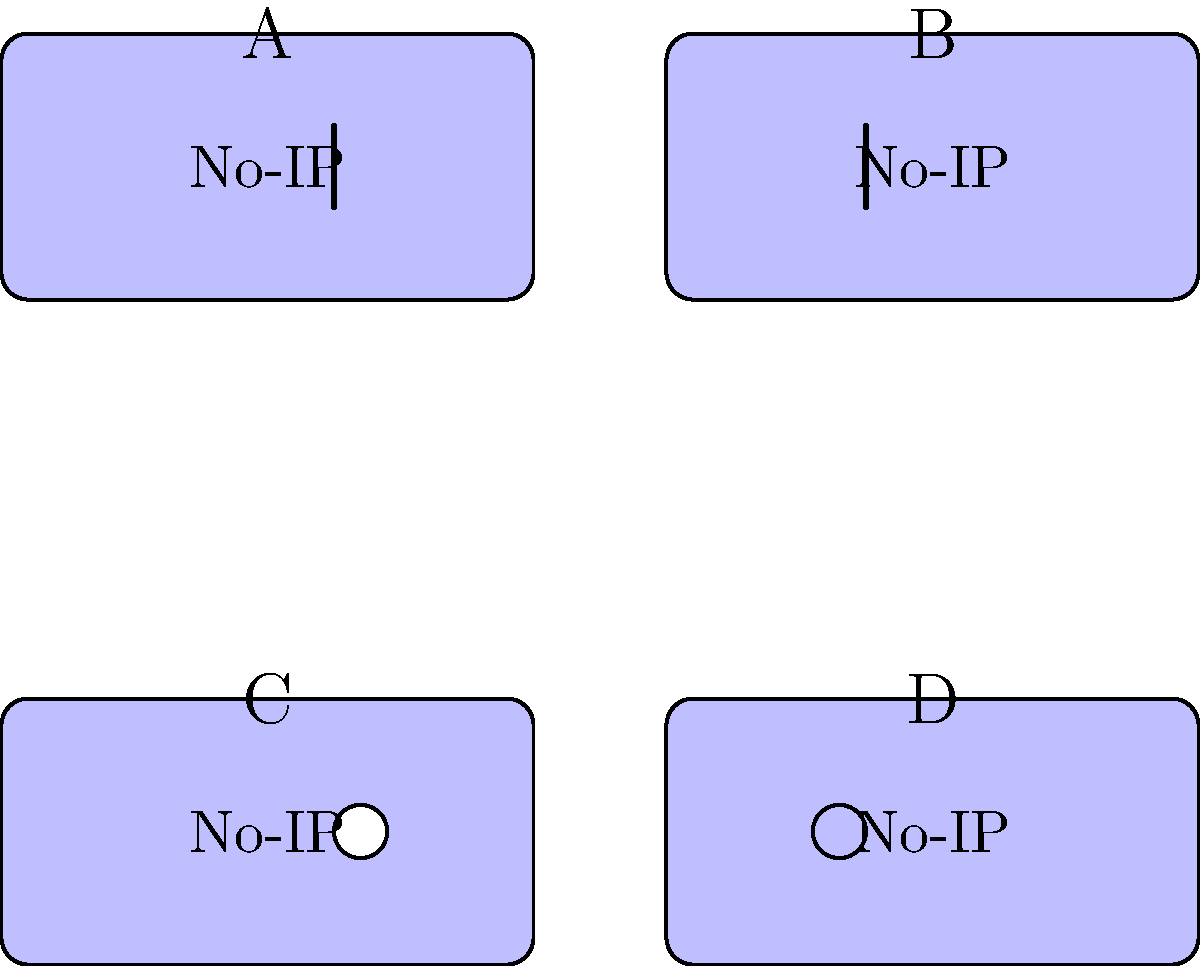Which of the following logos is the correct No-IP logo that Mike uses for his dynamic DNS service? To identify the correct No-IP logo, let's examine each option:

1. Logo A: This logo has an additional vertical line on the right side of the text. This is not a feature of the standard No-IP logo.

2. Logo B: This logo has an additional vertical line on the left side of the text. This is also not a feature of the standard No-IP logo.

3. Logo C: This logo has a white circle added to the right of the text. This is not part of the official No-IP logo design.

4. Logo D: This logo appears to be the simplest and most standard version. It has a blue background with white text, which is consistent with the typical No-IP branding.

The correct No-IP logo should be simple and clean, without any additional elements or modifications. Based on this, Logo D is the most likely to be the correct and official No-IP logo that Mike would use for his dynamic DNS service.
Answer: Logo D 